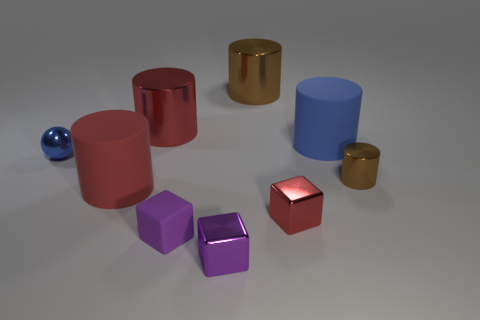How many other things are there of the same shape as the tiny blue thing?
Keep it short and to the point. 0. How many purple things are tiny things or big rubber things?
Your response must be concise. 2. Does the tiny brown thing have the same shape as the tiny purple metal thing?
Make the answer very short. No. There is a brown metallic thing right of the blue cylinder; are there any brown things right of it?
Provide a short and direct response. No. Is the number of large matte cylinders that are to the left of the red metallic block the same as the number of purple metallic cubes?
Your response must be concise. Yes. What number of other objects are there of the same size as the red shiny cylinder?
Offer a very short reply. 3. Does the red object behind the tiny cylinder have the same material as the large thing in front of the small brown metal object?
Ensure brevity in your answer.  No. What size is the brown thing to the left of the brown thing on the right side of the big brown metallic thing?
Provide a succinct answer. Large. Is there a cube that has the same color as the tiny cylinder?
Offer a terse response. No. There is a matte cylinder that is right of the matte block; is its color the same as the large matte thing in front of the sphere?
Offer a very short reply. No. 